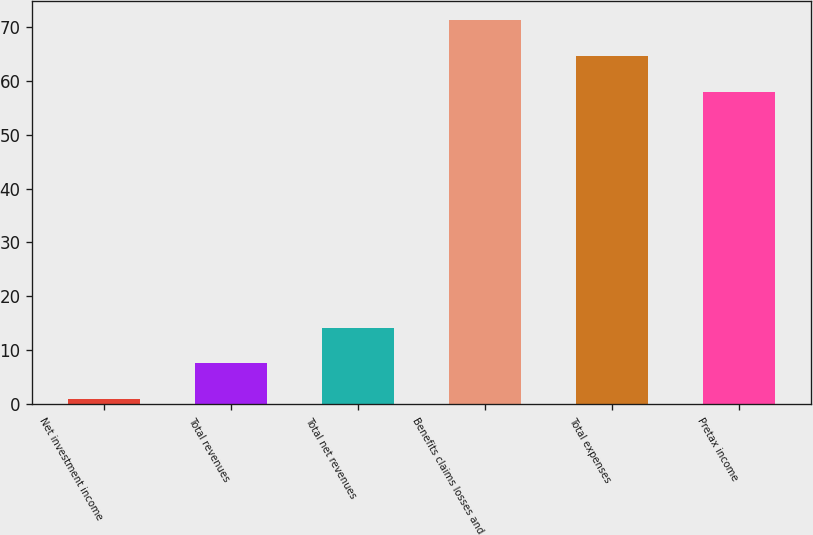Convert chart. <chart><loc_0><loc_0><loc_500><loc_500><bar_chart><fcel>Net investment income<fcel>Total revenues<fcel>Total net revenues<fcel>Benefits claims losses and<fcel>Total expenses<fcel>Pretax income<nl><fcel>1<fcel>7.6<fcel>14.2<fcel>71.2<fcel>64.6<fcel>58<nl></chart> 